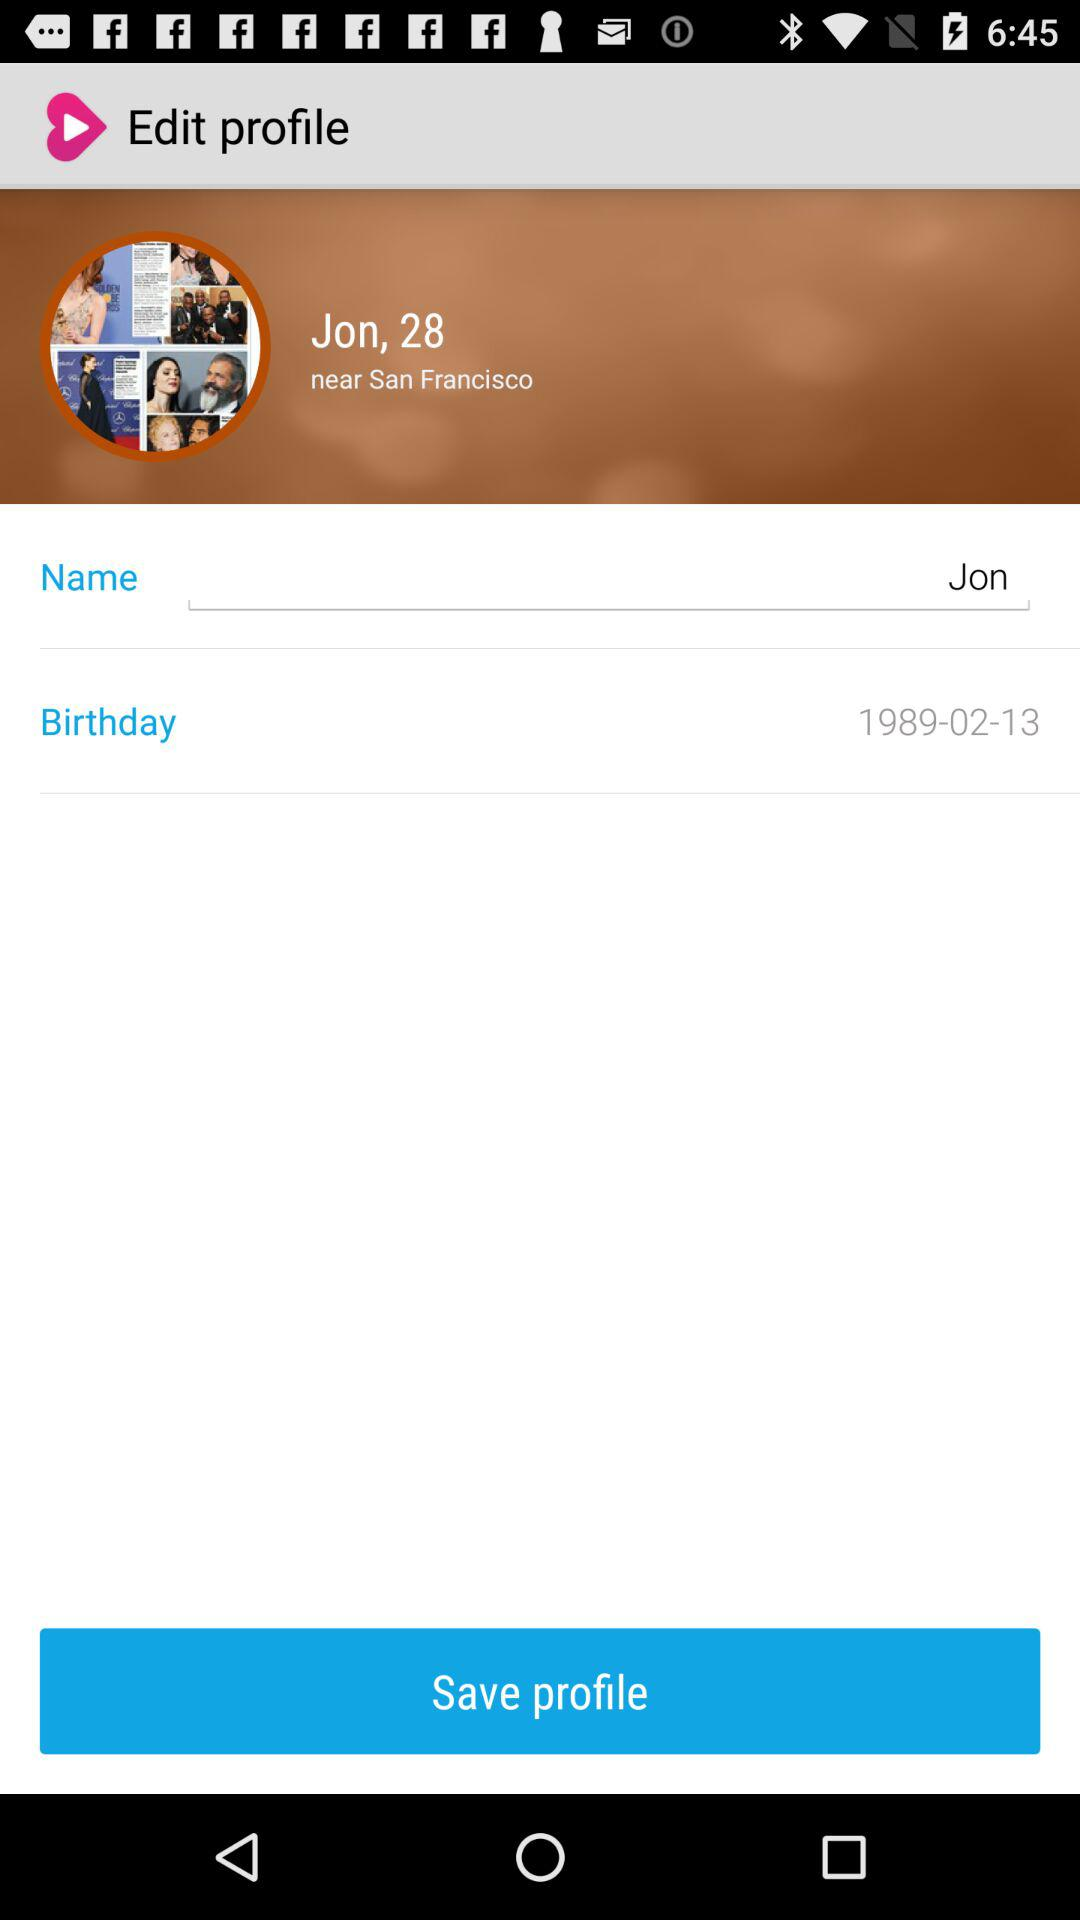What is the mentioned name? The mentioned name is Jon. 